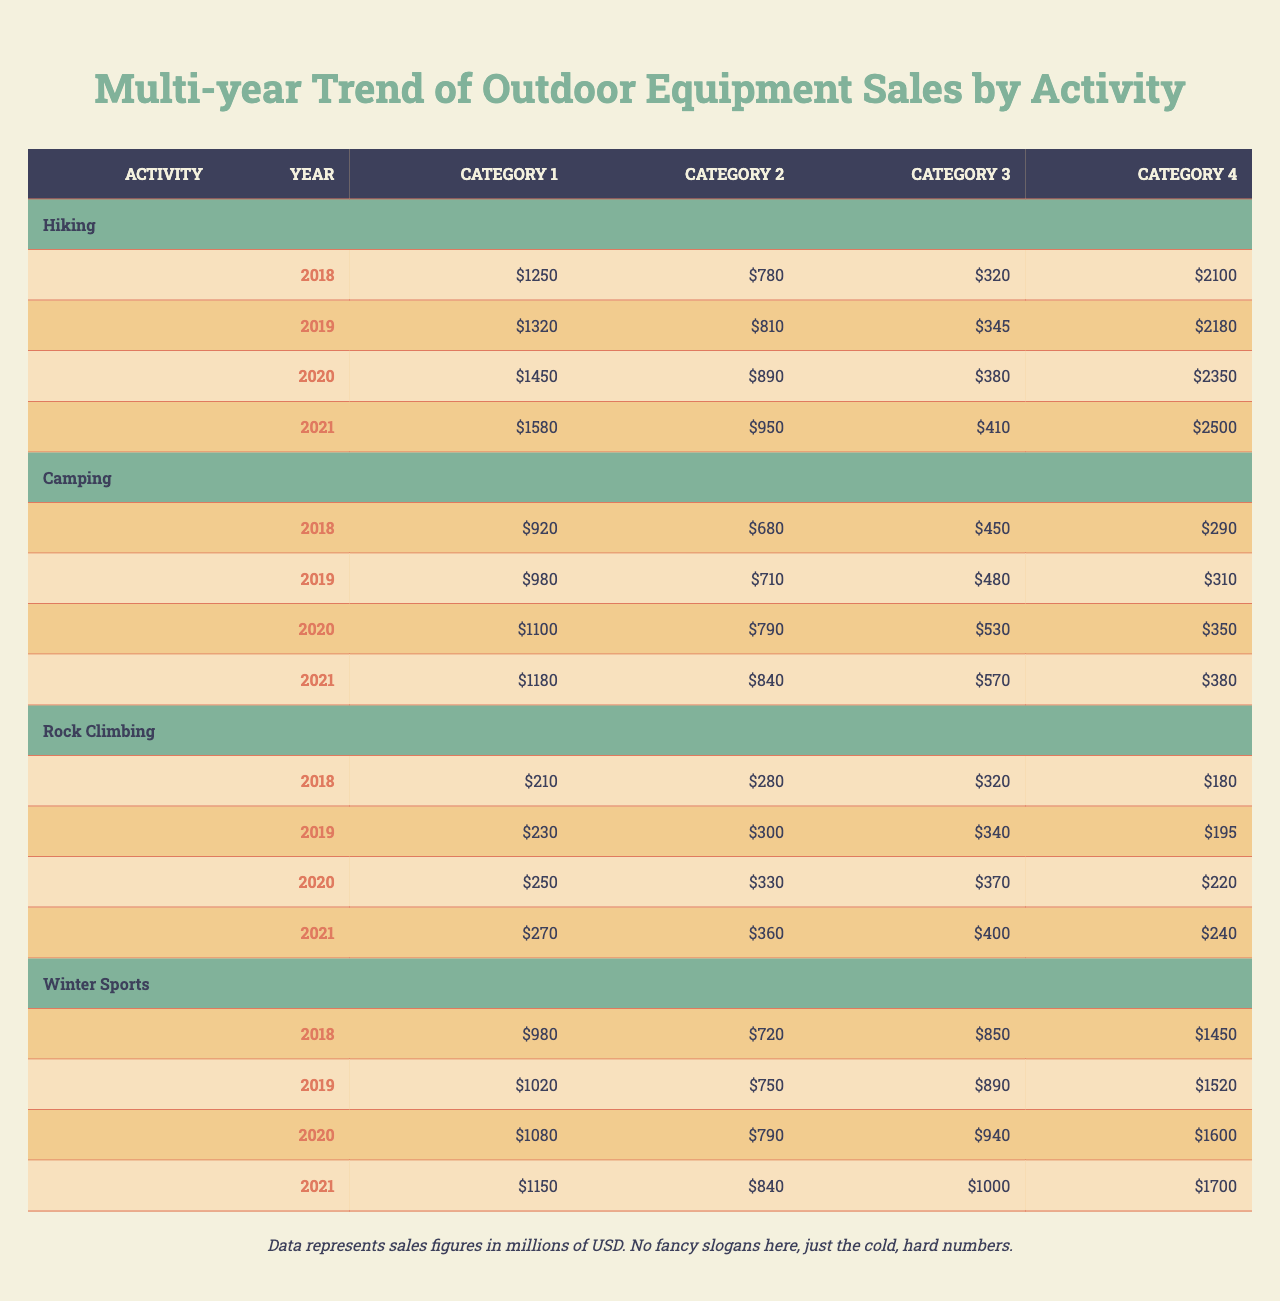What was the total sales for Hiking activity in 2020? For Hiking in 2020, the sales figures are: Footwear: 1450, Backpacks: 890, Trekking Poles: 380, and Clothing: 2350. Summing these up gives 1450 + 890 + 380 + 2350 = 5070 million USD.
Answer: 5070 million USD Which category had the highest sales in Camping for 2021? In the Camping activity for 2021, the sales figures are: Tents: 1180, Sleeping Bags: 840, Cooking Equipment: 570, and Lighting: 380. The highest sales are for Tents at 1180 million USD.
Answer: Tents What is the percentage increase in sales for Ski equipment from 2018 to 2021? For Skis in 2018, the sales were 980, and in 2021, they were 1150. The increase is 1150 - 980 = 170. The percentage increase is (170/980) * 100 = 17.35%.
Answer: 17.35% Which activity category had consistent growth from 2018 to 2021? Reviewing each activity's yearly sales shows all categories increased in sales from 2018 to 2021: Hiking, Camping, Rock Climbing, and Winter Sports all displayed year-on-year sales growth consistently.
Answer: Yes What was the total sales for Rock Climbing in 2019? In Rock Climbing for 2019, the sales figures are: Harnesses: 230, Ropes: 300, Climbing Shoes: 340, and Carabiners: 195. The total sales is 230 + 300 + 340 + 195 = 1065 million USD.
Answer: 1065 million USD In which year did Outdoor Equipment sales for Clothing in Hiking surpass 2500 million USD? By checking the sales for Clothing in Hiking, we see it reached 2500 million USD in 2021, as prior years (2018 to 2020) did not exceed this figure.
Answer: 2021 What is the average sales for Cooking Equipment across all years in Camping? The sales figures for Cooking Equipment are: 450 (2018), 480 (2019), 530 (2020), and 570 (2021). The average is (450 + 480 + 530 + 570) / 4 = 507.5 million USD.
Answer: 507.5 million USD Was there any decline in sales for Ropes in Rock Climbing between 2018 and 2019? Checking the recorded sales, Ropes in Rock Climbing were 280 in 2018 and increased to 300 in 2019, indicating no decline.
Answer: No What is the total sales difference in Outerwear between 2018 and 2021 for Winter Sports? The sales for Outerwear are 1450 in 2018 and 1700 in 2021. The difference is 1700 - 1450 = 250 million USD.
Answer: 250 million USD How much did sales for Sleeping Bags in Camping grow from 2018 to 2021? The sales for Sleeping Bags were 680 in 2018 and 840 in 2021. The growth is 840 - 680 = 160 million USD.
Answer: 160 million USD 